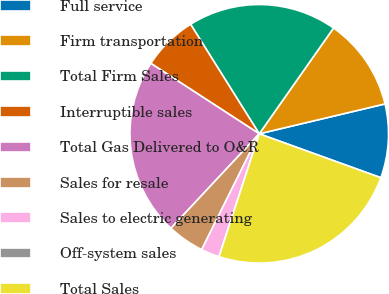<chart> <loc_0><loc_0><loc_500><loc_500><pie_chart><fcel>Full service<fcel>Firm transportation<fcel>Total Firm Sales<fcel>Interruptible sales<fcel>Total Gas Delivered to O&R<fcel>Sales for resale<fcel>Sales to electric generating<fcel>Off-system sales<fcel>Total Sales<nl><fcel>9.23%<fcel>11.54%<fcel>18.66%<fcel>6.92%<fcel>22.21%<fcel>4.62%<fcel>2.31%<fcel>0.0%<fcel>24.52%<nl></chart> 